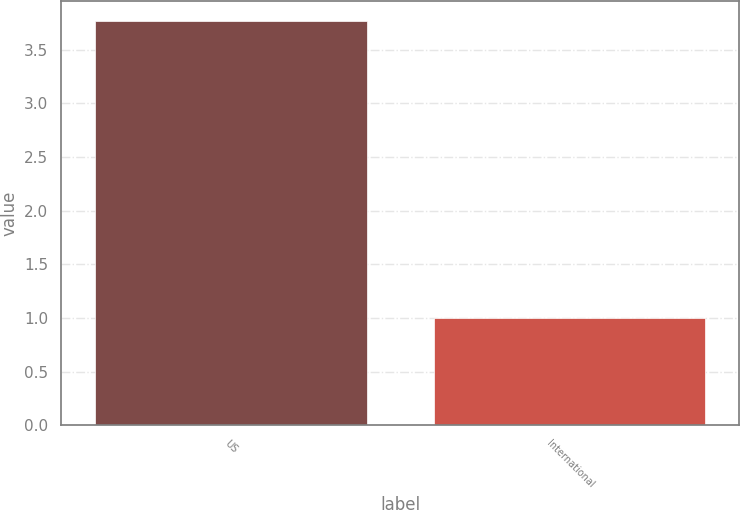Convert chart. <chart><loc_0><loc_0><loc_500><loc_500><bar_chart><fcel>US<fcel>International<nl><fcel>3.77<fcel>1<nl></chart> 